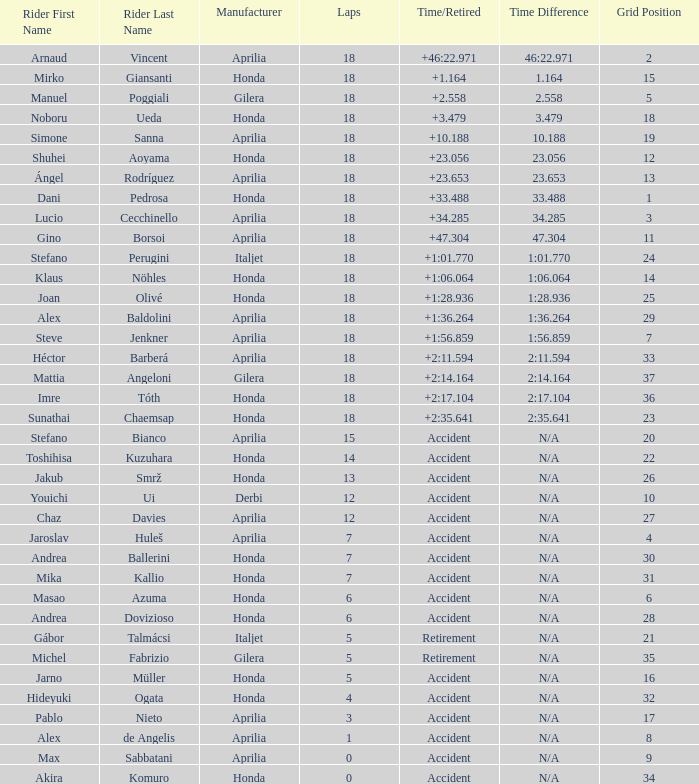What is the average number of laps with an accident time/retired, aprilia manufacturer and a grid of 27? 12.0. 